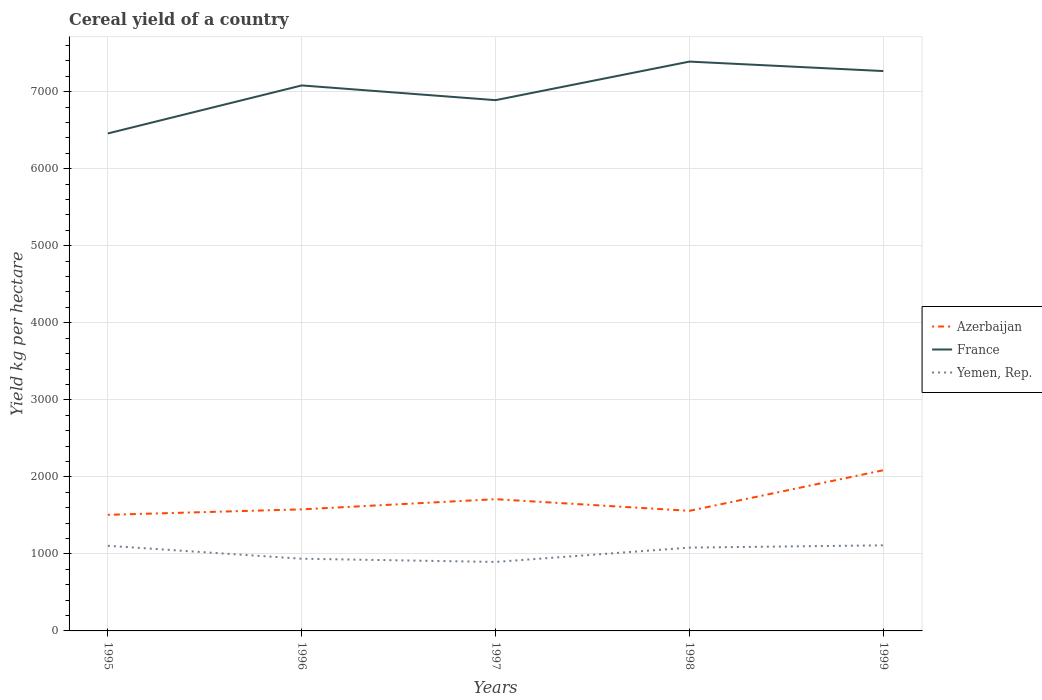Is the number of lines equal to the number of legend labels?
Give a very brief answer. Yes. Across all years, what is the maximum total cereal yield in France?
Provide a short and direct response. 6457.76. In which year was the total cereal yield in France maximum?
Offer a terse response. 1995. What is the total total cereal yield in Azerbaijan in the graph?
Make the answer very short. -132. What is the difference between the highest and the second highest total cereal yield in Yemen, Rep.?
Your answer should be very brief. 215.72. What is the difference between the highest and the lowest total cereal yield in Yemen, Rep.?
Ensure brevity in your answer.  3. Is the total cereal yield in Azerbaijan strictly greater than the total cereal yield in Yemen, Rep. over the years?
Your answer should be very brief. No. What is the difference between two consecutive major ticks on the Y-axis?
Your answer should be compact. 1000. Does the graph contain any zero values?
Keep it short and to the point. No. Where does the legend appear in the graph?
Offer a very short reply. Center right. What is the title of the graph?
Keep it short and to the point. Cereal yield of a country. Does "Saudi Arabia" appear as one of the legend labels in the graph?
Your answer should be very brief. No. What is the label or title of the Y-axis?
Give a very brief answer. Yield kg per hectare. What is the Yield kg per hectare of Azerbaijan in 1995?
Make the answer very short. 1507.06. What is the Yield kg per hectare of France in 1995?
Give a very brief answer. 6457.76. What is the Yield kg per hectare in Yemen, Rep. in 1995?
Provide a succinct answer. 1104.99. What is the Yield kg per hectare in Azerbaijan in 1996?
Keep it short and to the point. 1578.1. What is the Yield kg per hectare of France in 1996?
Provide a succinct answer. 7081.02. What is the Yield kg per hectare of Yemen, Rep. in 1996?
Give a very brief answer. 937.09. What is the Yield kg per hectare in Azerbaijan in 1997?
Keep it short and to the point. 1710.11. What is the Yield kg per hectare in France in 1997?
Offer a terse response. 6889.84. What is the Yield kg per hectare of Yemen, Rep. in 1997?
Your answer should be very brief. 895.44. What is the Yield kg per hectare in Azerbaijan in 1998?
Give a very brief answer. 1558.88. What is the Yield kg per hectare in France in 1998?
Provide a short and direct response. 7390.49. What is the Yield kg per hectare of Yemen, Rep. in 1998?
Your answer should be compact. 1081.46. What is the Yield kg per hectare in Azerbaijan in 1999?
Ensure brevity in your answer.  2085.95. What is the Yield kg per hectare in France in 1999?
Offer a terse response. 7267.58. What is the Yield kg per hectare of Yemen, Rep. in 1999?
Ensure brevity in your answer.  1111.16. Across all years, what is the maximum Yield kg per hectare in Azerbaijan?
Offer a very short reply. 2085.95. Across all years, what is the maximum Yield kg per hectare in France?
Your response must be concise. 7390.49. Across all years, what is the maximum Yield kg per hectare of Yemen, Rep.?
Make the answer very short. 1111.16. Across all years, what is the minimum Yield kg per hectare of Azerbaijan?
Ensure brevity in your answer.  1507.06. Across all years, what is the minimum Yield kg per hectare in France?
Provide a succinct answer. 6457.76. Across all years, what is the minimum Yield kg per hectare of Yemen, Rep.?
Give a very brief answer. 895.44. What is the total Yield kg per hectare of Azerbaijan in the graph?
Make the answer very short. 8440.1. What is the total Yield kg per hectare in France in the graph?
Make the answer very short. 3.51e+04. What is the total Yield kg per hectare in Yemen, Rep. in the graph?
Provide a short and direct response. 5130.15. What is the difference between the Yield kg per hectare in Azerbaijan in 1995 and that in 1996?
Ensure brevity in your answer.  -71.04. What is the difference between the Yield kg per hectare in France in 1995 and that in 1996?
Keep it short and to the point. -623.26. What is the difference between the Yield kg per hectare in Yemen, Rep. in 1995 and that in 1996?
Your answer should be compact. 167.91. What is the difference between the Yield kg per hectare in Azerbaijan in 1995 and that in 1997?
Give a very brief answer. -203.05. What is the difference between the Yield kg per hectare of France in 1995 and that in 1997?
Offer a very short reply. -432.08. What is the difference between the Yield kg per hectare in Yemen, Rep. in 1995 and that in 1997?
Give a very brief answer. 209.55. What is the difference between the Yield kg per hectare of Azerbaijan in 1995 and that in 1998?
Provide a succinct answer. -51.82. What is the difference between the Yield kg per hectare in France in 1995 and that in 1998?
Ensure brevity in your answer.  -932.73. What is the difference between the Yield kg per hectare in Yemen, Rep. in 1995 and that in 1998?
Provide a succinct answer. 23.53. What is the difference between the Yield kg per hectare of Azerbaijan in 1995 and that in 1999?
Provide a short and direct response. -578.88. What is the difference between the Yield kg per hectare of France in 1995 and that in 1999?
Your answer should be very brief. -809.82. What is the difference between the Yield kg per hectare of Yemen, Rep. in 1995 and that in 1999?
Offer a very short reply. -6.16. What is the difference between the Yield kg per hectare in Azerbaijan in 1996 and that in 1997?
Your answer should be compact. -132. What is the difference between the Yield kg per hectare in France in 1996 and that in 1997?
Make the answer very short. 191.18. What is the difference between the Yield kg per hectare of Yemen, Rep. in 1996 and that in 1997?
Your answer should be very brief. 41.64. What is the difference between the Yield kg per hectare of Azerbaijan in 1996 and that in 1998?
Keep it short and to the point. 19.23. What is the difference between the Yield kg per hectare of France in 1996 and that in 1998?
Your answer should be very brief. -309.47. What is the difference between the Yield kg per hectare in Yemen, Rep. in 1996 and that in 1998?
Provide a succinct answer. -144.37. What is the difference between the Yield kg per hectare of Azerbaijan in 1996 and that in 1999?
Ensure brevity in your answer.  -507.84. What is the difference between the Yield kg per hectare of France in 1996 and that in 1999?
Ensure brevity in your answer.  -186.56. What is the difference between the Yield kg per hectare of Yemen, Rep. in 1996 and that in 1999?
Make the answer very short. -174.07. What is the difference between the Yield kg per hectare in Azerbaijan in 1997 and that in 1998?
Provide a short and direct response. 151.23. What is the difference between the Yield kg per hectare in France in 1997 and that in 1998?
Provide a succinct answer. -500.65. What is the difference between the Yield kg per hectare of Yemen, Rep. in 1997 and that in 1998?
Give a very brief answer. -186.02. What is the difference between the Yield kg per hectare in Azerbaijan in 1997 and that in 1999?
Offer a very short reply. -375.84. What is the difference between the Yield kg per hectare in France in 1997 and that in 1999?
Provide a succinct answer. -377.74. What is the difference between the Yield kg per hectare in Yemen, Rep. in 1997 and that in 1999?
Make the answer very short. -215.72. What is the difference between the Yield kg per hectare in Azerbaijan in 1998 and that in 1999?
Keep it short and to the point. -527.07. What is the difference between the Yield kg per hectare in France in 1998 and that in 1999?
Keep it short and to the point. 122.91. What is the difference between the Yield kg per hectare of Yemen, Rep. in 1998 and that in 1999?
Offer a very short reply. -29.7. What is the difference between the Yield kg per hectare in Azerbaijan in 1995 and the Yield kg per hectare in France in 1996?
Give a very brief answer. -5573.96. What is the difference between the Yield kg per hectare of Azerbaijan in 1995 and the Yield kg per hectare of Yemen, Rep. in 1996?
Offer a very short reply. 569.97. What is the difference between the Yield kg per hectare of France in 1995 and the Yield kg per hectare of Yemen, Rep. in 1996?
Give a very brief answer. 5520.67. What is the difference between the Yield kg per hectare in Azerbaijan in 1995 and the Yield kg per hectare in France in 1997?
Ensure brevity in your answer.  -5382.78. What is the difference between the Yield kg per hectare of Azerbaijan in 1995 and the Yield kg per hectare of Yemen, Rep. in 1997?
Your answer should be compact. 611.62. What is the difference between the Yield kg per hectare of France in 1995 and the Yield kg per hectare of Yemen, Rep. in 1997?
Give a very brief answer. 5562.31. What is the difference between the Yield kg per hectare in Azerbaijan in 1995 and the Yield kg per hectare in France in 1998?
Keep it short and to the point. -5883.43. What is the difference between the Yield kg per hectare of Azerbaijan in 1995 and the Yield kg per hectare of Yemen, Rep. in 1998?
Offer a very short reply. 425.6. What is the difference between the Yield kg per hectare of France in 1995 and the Yield kg per hectare of Yemen, Rep. in 1998?
Provide a short and direct response. 5376.3. What is the difference between the Yield kg per hectare of Azerbaijan in 1995 and the Yield kg per hectare of France in 1999?
Give a very brief answer. -5760.52. What is the difference between the Yield kg per hectare in Azerbaijan in 1995 and the Yield kg per hectare in Yemen, Rep. in 1999?
Provide a succinct answer. 395.9. What is the difference between the Yield kg per hectare in France in 1995 and the Yield kg per hectare in Yemen, Rep. in 1999?
Offer a terse response. 5346.6. What is the difference between the Yield kg per hectare in Azerbaijan in 1996 and the Yield kg per hectare in France in 1997?
Your answer should be very brief. -5311.73. What is the difference between the Yield kg per hectare in Azerbaijan in 1996 and the Yield kg per hectare in Yemen, Rep. in 1997?
Provide a short and direct response. 682.66. What is the difference between the Yield kg per hectare of France in 1996 and the Yield kg per hectare of Yemen, Rep. in 1997?
Give a very brief answer. 6185.58. What is the difference between the Yield kg per hectare in Azerbaijan in 1996 and the Yield kg per hectare in France in 1998?
Offer a very short reply. -5812.39. What is the difference between the Yield kg per hectare of Azerbaijan in 1996 and the Yield kg per hectare of Yemen, Rep. in 1998?
Offer a terse response. 496.64. What is the difference between the Yield kg per hectare in France in 1996 and the Yield kg per hectare in Yemen, Rep. in 1998?
Your answer should be very brief. 5999.56. What is the difference between the Yield kg per hectare of Azerbaijan in 1996 and the Yield kg per hectare of France in 1999?
Provide a short and direct response. -5689.47. What is the difference between the Yield kg per hectare of Azerbaijan in 1996 and the Yield kg per hectare of Yemen, Rep. in 1999?
Ensure brevity in your answer.  466.94. What is the difference between the Yield kg per hectare of France in 1996 and the Yield kg per hectare of Yemen, Rep. in 1999?
Your answer should be compact. 5969.86. What is the difference between the Yield kg per hectare of Azerbaijan in 1997 and the Yield kg per hectare of France in 1998?
Provide a short and direct response. -5680.38. What is the difference between the Yield kg per hectare in Azerbaijan in 1997 and the Yield kg per hectare in Yemen, Rep. in 1998?
Your answer should be very brief. 628.65. What is the difference between the Yield kg per hectare in France in 1997 and the Yield kg per hectare in Yemen, Rep. in 1998?
Keep it short and to the point. 5808.38. What is the difference between the Yield kg per hectare in Azerbaijan in 1997 and the Yield kg per hectare in France in 1999?
Provide a succinct answer. -5557.47. What is the difference between the Yield kg per hectare of Azerbaijan in 1997 and the Yield kg per hectare of Yemen, Rep. in 1999?
Your answer should be compact. 598.95. What is the difference between the Yield kg per hectare of France in 1997 and the Yield kg per hectare of Yemen, Rep. in 1999?
Your answer should be compact. 5778.68. What is the difference between the Yield kg per hectare in Azerbaijan in 1998 and the Yield kg per hectare in France in 1999?
Give a very brief answer. -5708.7. What is the difference between the Yield kg per hectare of Azerbaijan in 1998 and the Yield kg per hectare of Yemen, Rep. in 1999?
Your response must be concise. 447.72. What is the difference between the Yield kg per hectare of France in 1998 and the Yield kg per hectare of Yemen, Rep. in 1999?
Provide a succinct answer. 6279.33. What is the average Yield kg per hectare of Azerbaijan per year?
Give a very brief answer. 1688.02. What is the average Yield kg per hectare of France per year?
Ensure brevity in your answer.  7017.34. What is the average Yield kg per hectare in Yemen, Rep. per year?
Your answer should be compact. 1026.03. In the year 1995, what is the difference between the Yield kg per hectare of Azerbaijan and Yield kg per hectare of France?
Keep it short and to the point. -4950.7. In the year 1995, what is the difference between the Yield kg per hectare in Azerbaijan and Yield kg per hectare in Yemen, Rep.?
Your response must be concise. 402.07. In the year 1995, what is the difference between the Yield kg per hectare in France and Yield kg per hectare in Yemen, Rep.?
Your answer should be compact. 5352.76. In the year 1996, what is the difference between the Yield kg per hectare in Azerbaijan and Yield kg per hectare in France?
Provide a succinct answer. -5502.92. In the year 1996, what is the difference between the Yield kg per hectare in Azerbaijan and Yield kg per hectare in Yemen, Rep.?
Give a very brief answer. 641.02. In the year 1996, what is the difference between the Yield kg per hectare of France and Yield kg per hectare of Yemen, Rep.?
Ensure brevity in your answer.  6143.93. In the year 1997, what is the difference between the Yield kg per hectare in Azerbaijan and Yield kg per hectare in France?
Your answer should be compact. -5179.73. In the year 1997, what is the difference between the Yield kg per hectare of Azerbaijan and Yield kg per hectare of Yemen, Rep.?
Provide a short and direct response. 814.66. In the year 1997, what is the difference between the Yield kg per hectare in France and Yield kg per hectare in Yemen, Rep.?
Make the answer very short. 5994.39. In the year 1998, what is the difference between the Yield kg per hectare in Azerbaijan and Yield kg per hectare in France?
Ensure brevity in your answer.  -5831.61. In the year 1998, what is the difference between the Yield kg per hectare of Azerbaijan and Yield kg per hectare of Yemen, Rep.?
Make the answer very short. 477.42. In the year 1998, what is the difference between the Yield kg per hectare of France and Yield kg per hectare of Yemen, Rep.?
Your answer should be very brief. 6309.03. In the year 1999, what is the difference between the Yield kg per hectare in Azerbaijan and Yield kg per hectare in France?
Keep it short and to the point. -5181.63. In the year 1999, what is the difference between the Yield kg per hectare of Azerbaijan and Yield kg per hectare of Yemen, Rep.?
Offer a terse response. 974.79. In the year 1999, what is the difference between the Yield kg per hectare of France and Yield kg per hectare of Yemen, Rep.?
Ensure brevity in your answer.  6156.42. What is the ratio of the Yield kg per hectare in Azerbaijan in 1995 to that in 1996?
Offer a terse response. 0.95. What is the ratio of the Yield kg per hectare in France in 1995 to that in 1996?
Provide a succinct answer. 0.91. What is the ratio of the Yield kg per hectare of Yemen, Rep. in 1995 to that in 1996?
Your answer should be very brief. 1.18. What is the ratio of the Yield kg per hectare of Azerbaijan in 1995 to that in 1997?
Offer a terse response. 0.88. What is the ratio of the Yield kg per hectare in France in 1995 to that in 1997?
Ensure brevity in your answer.  0.94. What is the ratio of the Yield kg per hectare in Yemen, Rep. in 1995 to that in 1997?
Ensure brevity in your answer.  1.23. What is the ratio of the Yield kg per hectare in Azerbaijan in 1995 to that in 1998?
Provide a succinct answer. 0.97. What is the ratio of the Yield kg per hectare in France in 1995 to that in 1998?
Ensure brevity in your answer.  0.87. What is the ratio of the Yield kg per hectare of Yemen, Rep. in 1995 to that in 1998?
Your response must be concise. 1.02. What is the ratio of the Yield kg per hectare in Azerbaijan in 1995 to that in 1999?
Your response must be concise. 0.72. What is the ratio of the Yield kg per hectare of France in 1995 to that in 1999?
Provide a succinct answer. 0.89. What is the ratio of the Yield kg per hectare in Azerbaijan in 1996 to that in 1997?
Offer a very short reply. 0.92. What is the ratio of the Yield kg per hectare of France in 1996 to that in 1997?
Ensure brevity in your answer.  1.03. What is the ratio of the Yield kg per hectare in Yemen, Rep. in 1996 to that in 1997?
Provide a short and direct response. 1.05. What is the ratio of the Yield kg per hectare of Azerbaijan in 1996 to that in 1998?
Provide a short and direct response. 1.01. What is the ratio of the Yield kg per hectare in France in 1996 to that in 1998?
Provide a succinct answer. 0.96. What is the ratio of the Yield kg per hectare in Yemen, Rep. in 1996 to that in 1998?
Your response must be concise. 0.87. What is the ratio of the Yield kg per hectare in Azerbaijan in 1996 to that in 1999?
Provide a short and direct response. 0.76. What is the ratio of the Yield kg per hectare in France in 1996 to that in 1999?
Give a very brief answer. 0.97. What is the ratio of the Yield kg per hectare in Yemen, Rep. in 1996 to that in 1999?
Make the answer very short. 0.84. What is the ratio of the Yield kg per hectare of Azerbaijan in 1997 to that in 1998?
Keep it short and to the point. 1.1. What is the ratio of the Yield kg per hectare in France in 1997 to that in 1998?
Your answer should be compact. 0.93. What is the ratio of the Yield kg per hectare in Yemen, Rep. in 1997 to that in 1998?
Ensure brevity in your answer.  0.83. What is the ratio of the Yield kg per hectare in Azerbaijan in 1997 to that in 1999?
Keep it short and to the point. 0.82. What is the ratio of the Yield kg per hectare of France in 1997 to that in 1999?
Offer a terse response. 0.95. What is the ratio of the Yield kg per hectare in Yemen, Rep. in 1997 to that in 1999?
Give a very brief answer. 0.81. What is the ratio of the Yield kg per hectare of Azerbaijan in 1998 to that in 1999?
Make the answer very short. 0.75. What is the ratio of the Yield kg per hectare of France in 1998 to that in 1999?
Keep it short and to the point. 1.02. What is the ratio of the Yield kg per hectare of Yemen, Rep. in 1998 to that in 1999?
Ensure brevity in your answer.  0.97. What is the difference between the highest and the second highest Yield kg per hectare of Azerbaijan?
Offer a very short reply. 375.84. What is the difference between the highest and the second highest Yield kg per hectare of France?
Offer a very short reply. 122.91. What is the difference between the highest and the second highest Yield kg per hectare in Yemen, Rep.?
Offer a terse response. 6.16. What is the difference between the highest and the lowest Yield kg per hectare in Azerbaijan?
Offer a very short reply. 578.88. What is the difference between the highest and the lowest Yield kg per hectare of France?
Provide a short and direct response. 932.73. What is the difference between the highest and the lowest Yield kg per hectare in Yemen, Rep.?
Your answer should be very brief. 215.72. 